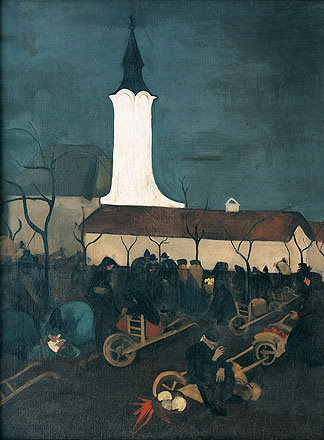What's happening in the scene? The image depicts an oil painting of a church scene. The church, with its tall white steeple, stands as a beacon against the dark sky. It's surrounded by trees and people, adding life to the otherwise serene landscape. The people, dressed in dark clothing, are engaged in various activities, carrying objects like a wheelbarrow and a ladder, suggesting a sense of community and cooperation. The art style is reminiscent of the post-impressionist movement, characterized by the use of dark colors and loose brushstrokes, lending a sense of movement and emotion to the scene. The genre of the painting is landscape, focusing on the natural and man-made elements of the environment. 